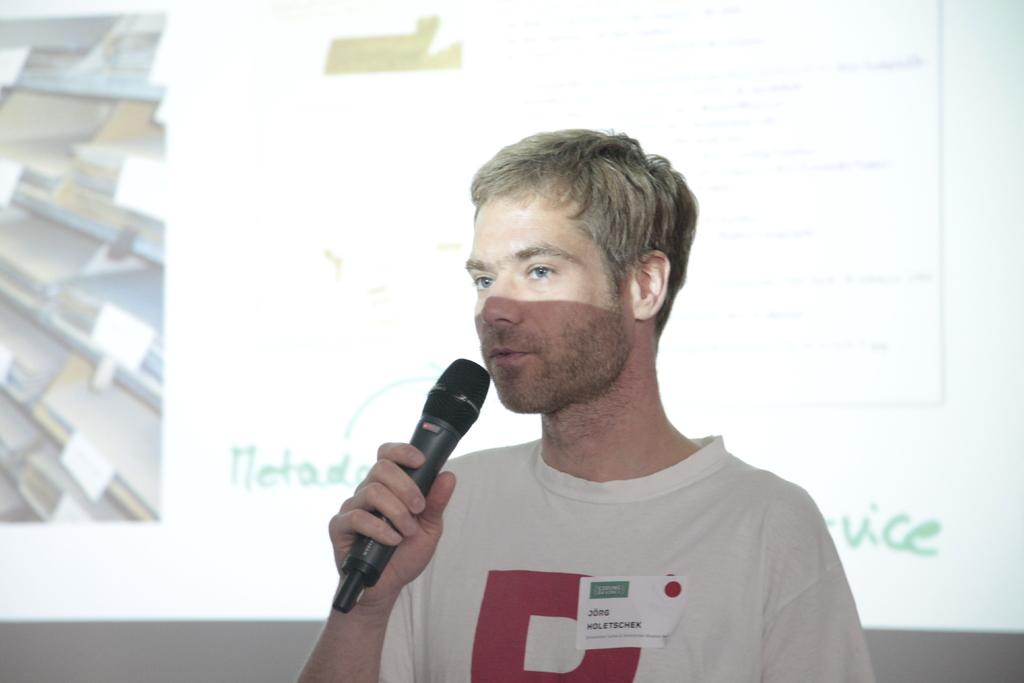What is the man in the image doing? The man is standing in the image and holding a mic. What object is the man holding in the image? The man is holding a mic. What can be seen in the background of the image? There is a screen visible in the background of the image. What type of stew is being prepared on the screen in the image? There is no stew or any cooking activity visible on the screen in the image. Can you see any scissors in the image? There are no scissors present in the image. 